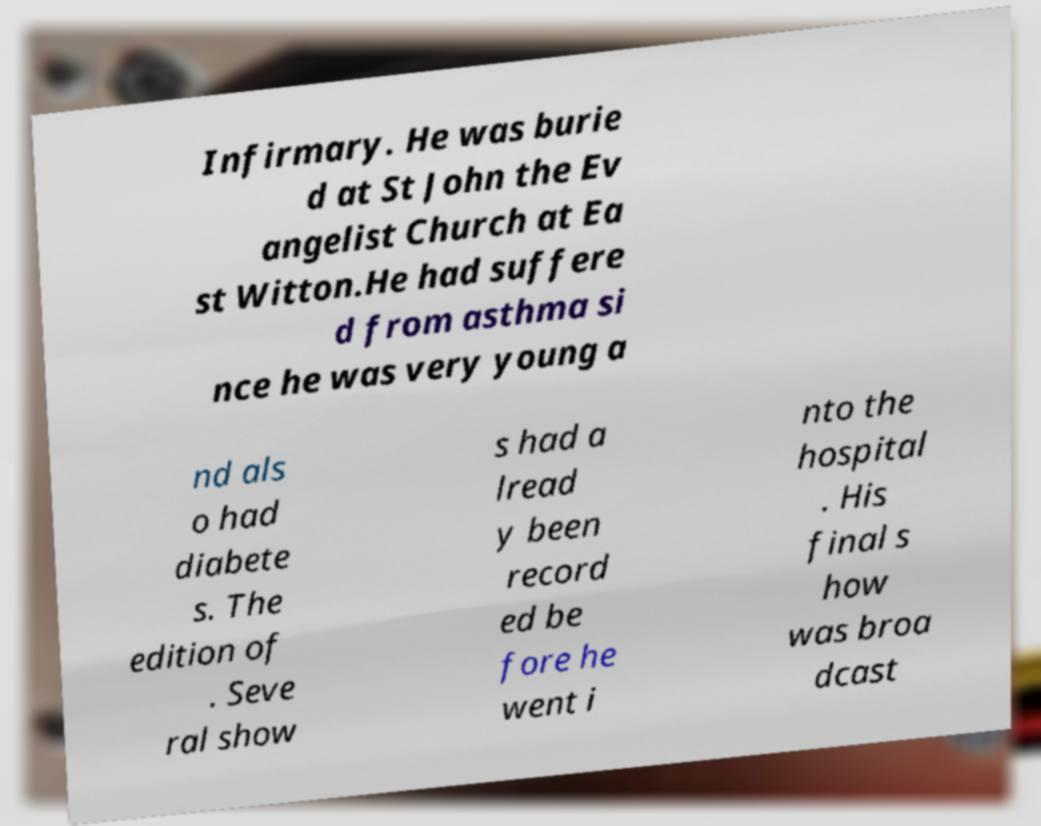Please identify and transcribe the text found in this image. Infirmary. He was burie d at St John the Ev angelist Church at Ea st Witton.He had suffere d from asthma si nce he was very young a nd als o had diabete s. The edition of . Seve ral show s had a lread y been record ed be fore he went i nto the hospital . His final s how was broa dcast 